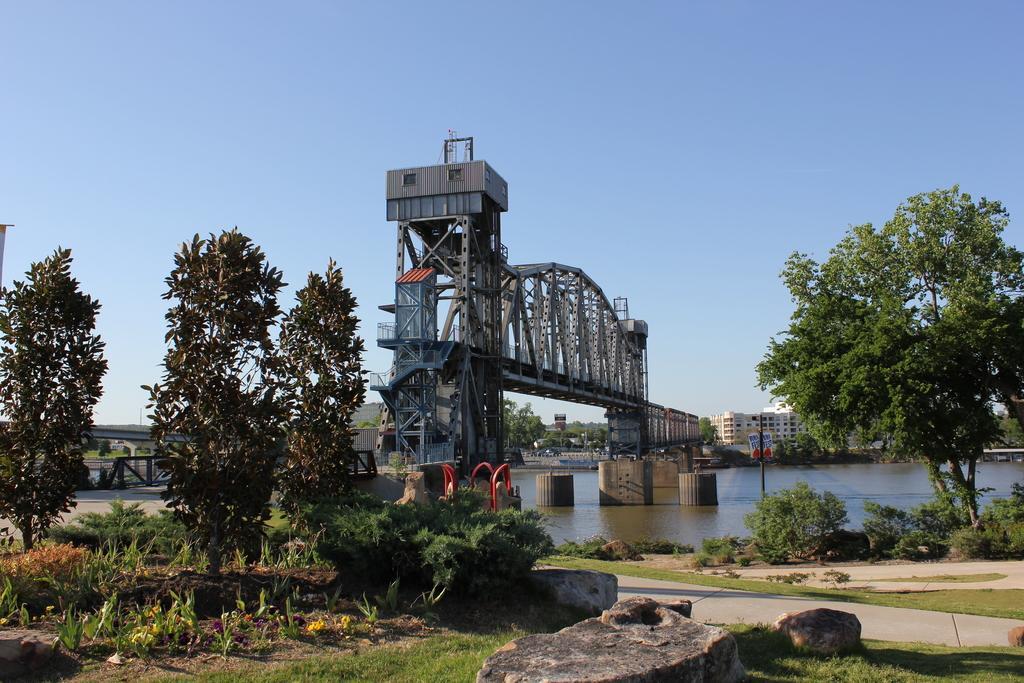Could you give a brief overview of what you see in this image? In this image, we can see trees, buildings, a bridge, plants, rocks, rods, poles, boards and at the bottom, there is water and ground. At the top, there is sky. 